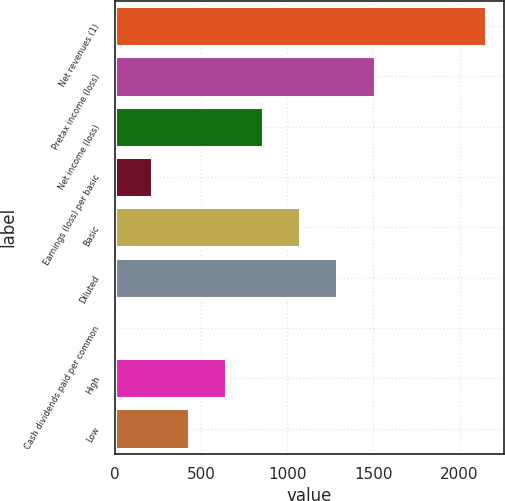Convert chart to OTSL. <chart><loc_0><loc_0><loc_500><loc_500><bar_chart><fcel>Net revenues (1)<fcel>Pretax income (loss)<fcel>Net income (loss)<fcel>Earnings (loss) per basic<fcel>Basic<fcel>Diluted<fcel>Cash dividends paid per common<fcel>High<fcel>Low<nl><fcel>2153<fcel>1507.15<fcel>861.29<fcel>215.44<fcel>1076.58<fcel>1291.87<fcel>0.15<fcel>646.01<fcel>430.73<nl></chart> 